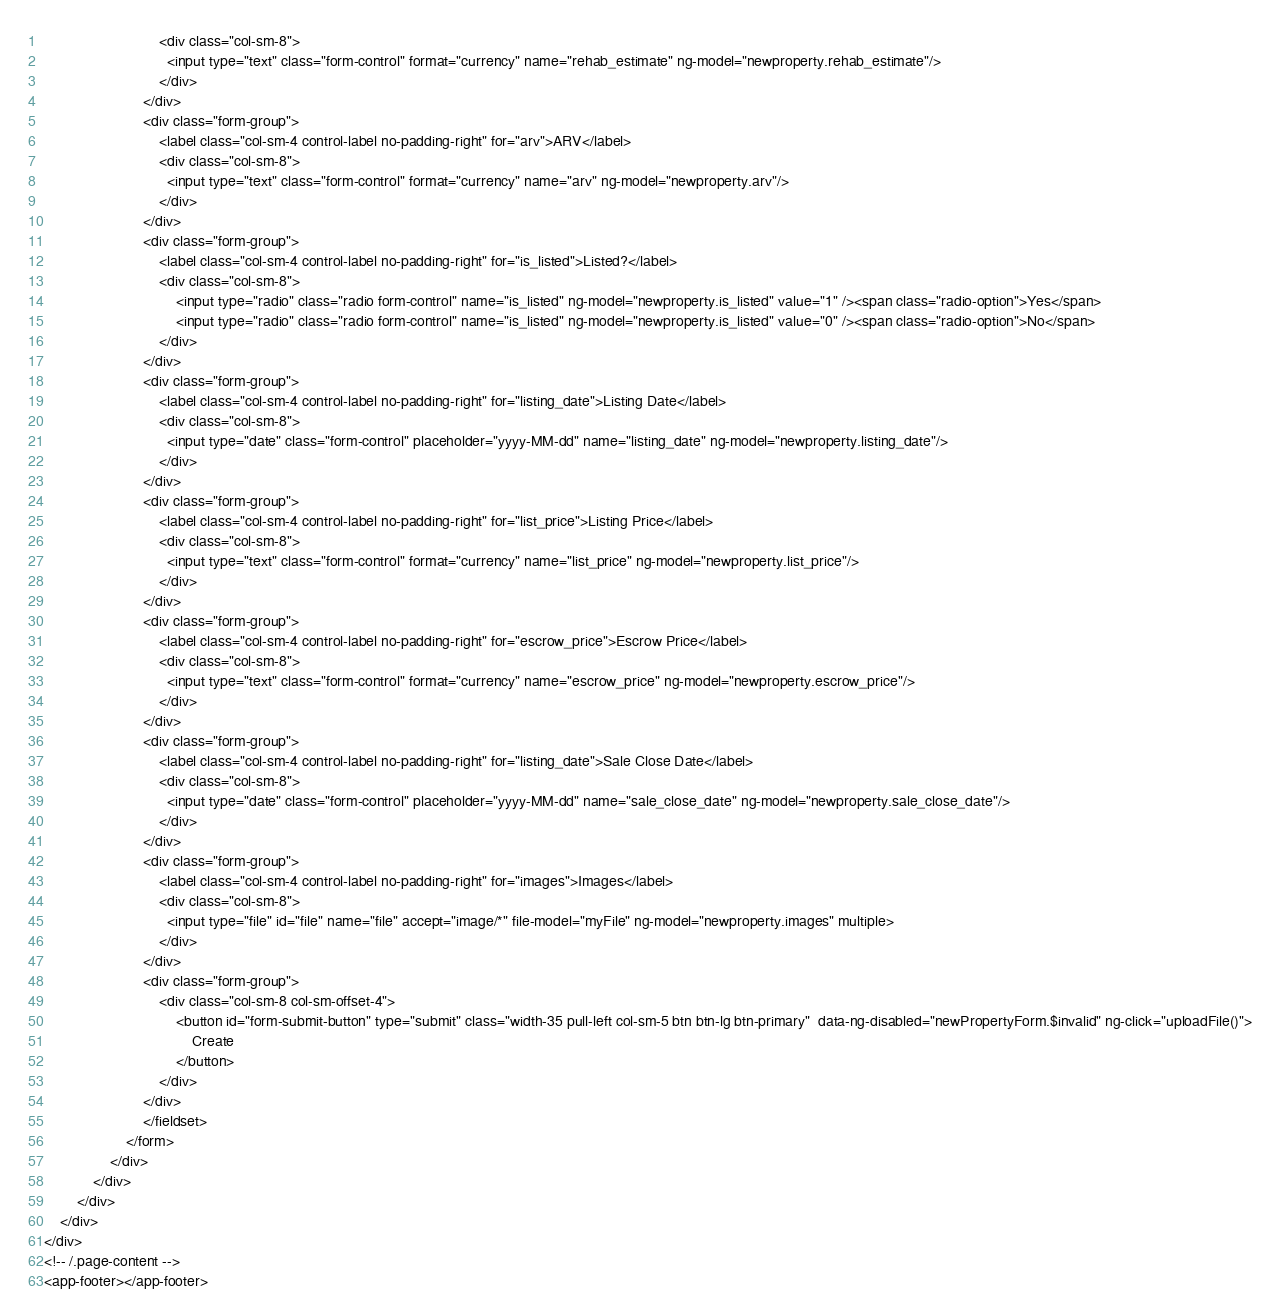<code> <loc_0><loc_0><loc_500><loc_500><_HTML_>                            <div class="col-sm-8">
                              <input type="text" class="form-control" format="currency" name="rehab_estimate" ng-model="newproperty.rehab_estimate"/>
                            </div>
                        </div>
                        <div class="form-group">
                            <label class="col-sm-4 control-label no-padding-right" for="arv">ARV</label>
                            <div class="col-sm-8">
                              <input type="text" class="form-control" format="currency" name="arv" ng-model="newproperty.arv"/>
                            </div>
                        </div>
                        <div class="form-group">
                            <label class="col-sm-4 control-label no-padding-right" for="is_listed">Listed?</label>
                            <div class="col-sm-8">
                                <input type="radio" class="radio form-control" name="is_listed" ng-model="newproperty.is_listed" value="1" /><span class="radio-option">Yes</span>
                                <input type="radio" class="radio form-control" name="is_listed" ng-model="newproperty.is_listed" value="0" /><span class="radio-option">No</span>
                            </div>
                        </div>
                        <div class="form-group">
                            <label class="col-sm-4 control-label no-padding-right" for="listing_date">Listing Date</label>
                            <div class="col-sm-8">
                              <input type="date" class="form-control" placeholder="yyyy-MM-dd" name="listing_date" ng-model="newproperty.listing_date"/>
                            </div>
                        </div>
                        <div class="form-group">
                            <label class="col-sm-4 control-label no-padding-right" for="list_price">Listing Price</label>
                            <div class="col-sm-8">
                              <input type="text" class="form-control" format="currency" name="list_price" ng-model="newproperty.list_price"/>
                            </div>
                        </div>
                        <div class="form-group">
                            <label class="col-sm-4 control-label no-padding-right" for="escrow_price">Escrow Price</label>
                            <div class="col-sm-8">
                              <input type="text" class="form-control" format="currency" name="escrow_price" ng-model="newproperty.escrow_price"/>
                            </div>
                        </div>
                        <div class="form-group">
                            <label class="col-sm-4 control-label no-padding-right" for="listing_date">Sale Close Date</label>
                            <div class="col-sm-8">
                              <input type="date" class="form-control" placeholder="yyyy-MM-dd" name="sale_close_date" ng-model="newproperty.sale_close_date"/>
                            </div>
                        </div>
                        <div class="form-group">
                            <label class="col-sm-4 control-label no-padding-right" for="images">Images</label>
                            <div class="col-sm-8">
                              <input type="file" id="file" name="file" accept="image/*" file-model="myFile" ng-model="newproperty.images" multiple>
                            </div>
                        </div>
                        <div class="form-group">
                            <div class="col-sm-8 col-sm-offset-4">
                                <button id="form-submit-button" type="submit" class="width-35 pull-left col-sm-5 btn btn-lg btn-primary"  data-ng-disabled="newPropertyForm.$invalid" ng-click="uploadFile()">
                                    Create
                                </button>
                            </div>
                        </div>
                        </fieldset>
                    </form>
                </div>
            </div>
        </div>
    </div>
</div>
<!-- /.page-content -->
<app-footer></app-footer></code> 